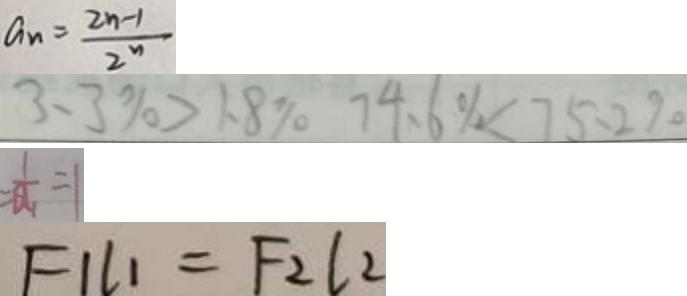Convert formula to latex. <formula><loc_0><loc_0><loc_500><loc_500>a _ { n } = \frac { 2 n - 1 } { 2 ^ { n } } 
 3 . 3 \% > 1 . 8 \% 7 4 . 6 \% < 7 5 . 2 \% 
 = \frac { 1 } { a _ { 1 } } = 1 
 F 1 l _ { 1 } = F _ { 2 } l _ { 2 }</formula> 